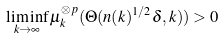Convert formula to latex. <formula><loc_0><loc_0><loc_500><loc_500>\liminf _ { k \to \infty } \mu _ { k } ^ { \otimes p } ( \Theta ( n ( k ) ^ { 1 / 2 } \delta , k ) ) > 0</formula> 